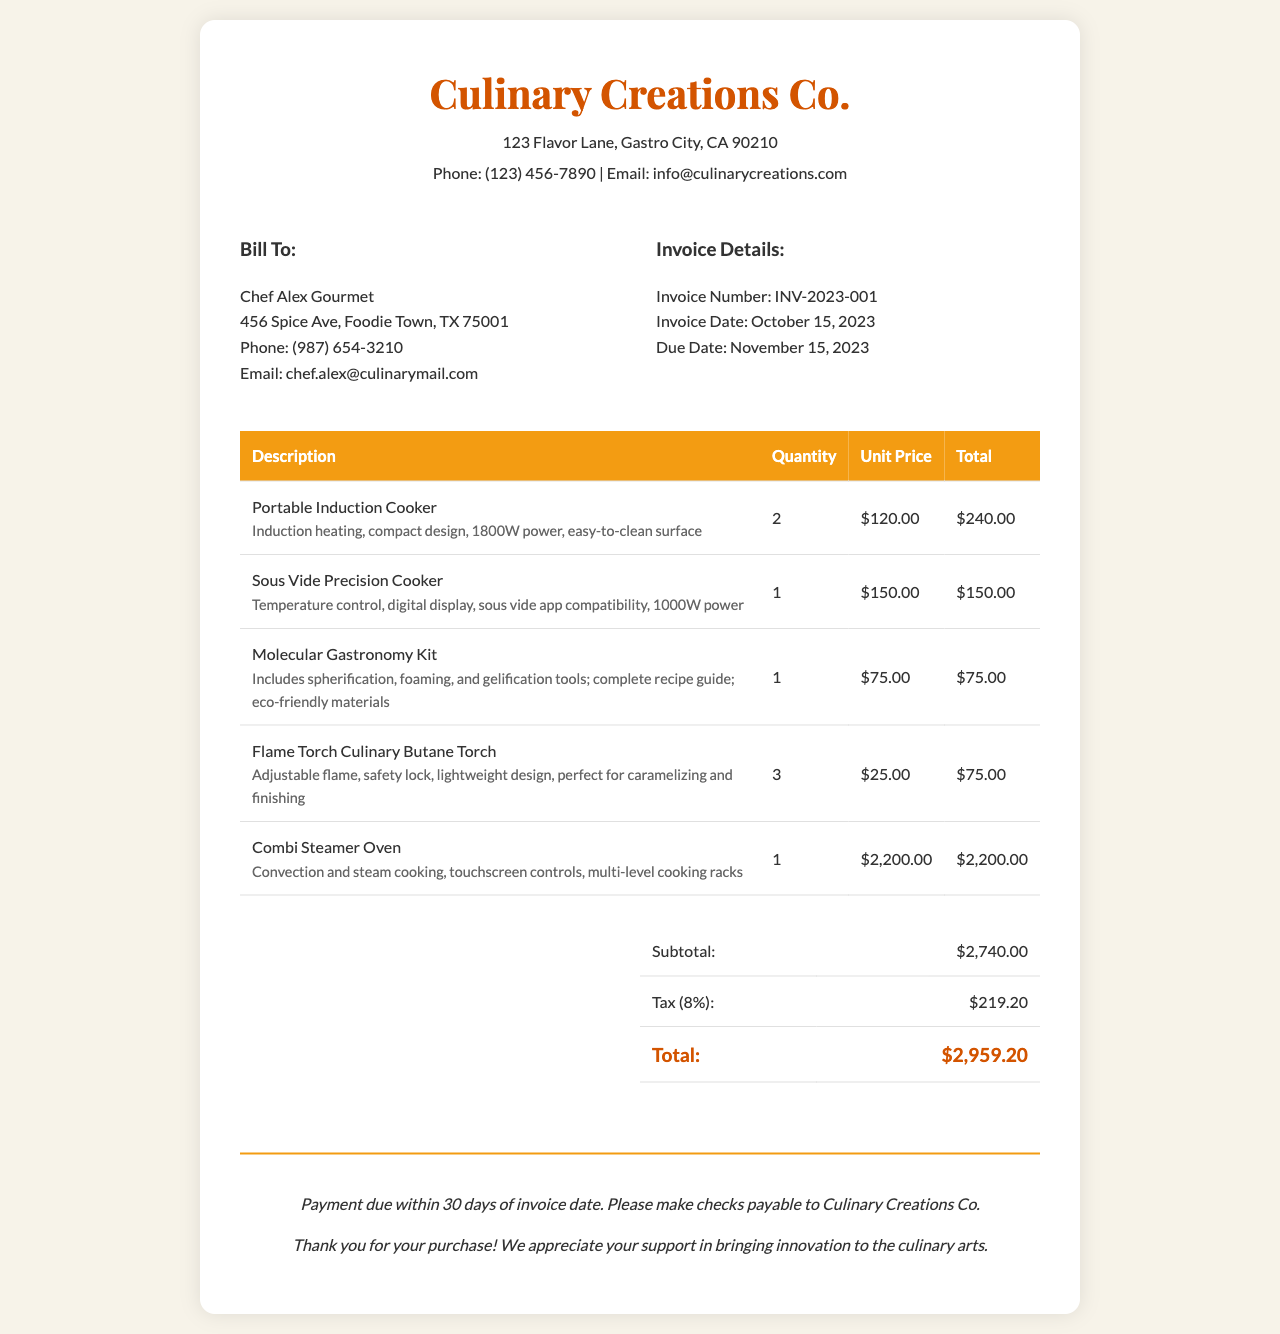What is the invoice number? The invoice number is specified in the document as the unique identifier for this transaction.
Answer: INV-2023-001 What is the total cost of the Portable Induction Cooker? The cost is derived from the unit price multiplied by the quantity ordered, specifically noted in the invoice total for that item.
Answer: $240.00 Who is the bill to? The document identifies the customer to whom the invoice is addressed, including their name and contact details.
Answer: Chef Alex Gourmet What is the due date for payment? The due date is provided in the invoice details section, indicating when payment should be made by the customer.
Answer: November 15, 2023 How many items are listed in the invoice? The total items count can be obtained by counting the rows in the itemized section of the invoice.
Answer: 5 What is the subtotal before tax? The subtotal is the total cost of all items before applying tax, uniquely specified in the summary section.
Answer: $2,740.00 What is the tax rate applied to the subtotal? The tax rate is explicitly noted in the summary section of the invoice, which applies to the subtotal.
Answer: 8% What is the main feature of the Combi Steamer Oven? One specific feature of the Combi Steamer Oven is highlighted in the document as a selling point for this kitchen gadget.
Answer: Convection and steam cooking What is the contact email for Culinary Creations Co.? The contact email is stated in the company information at the top of the invoice, providing a way for customers to reach out.
Answer: info@culinarycreations.com 